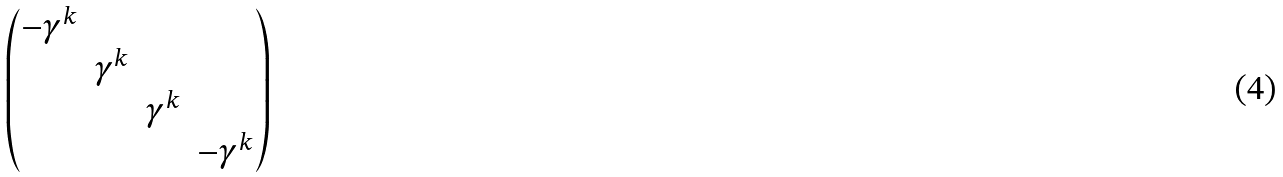<formula> <loc_0><loc_0><loc_500><loc_500>\begin{pmatrix} - \gamma ^ { k } & & & \\ & \gamma ^ { k } & & \\ & & \gamma ^ { k } & \\ & & & - \gamma ^ { k } \\ \end{pmatrix}</formula> 